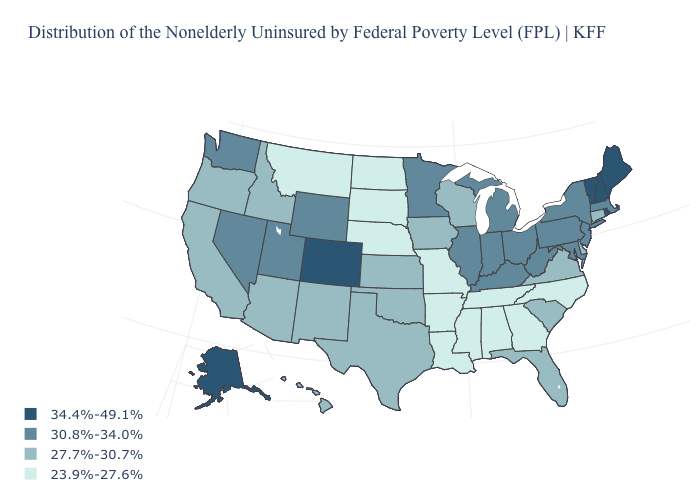Does Tennessee have the lowest value in the USA?
Be succinct. Yes. What is the value of Maine?
Give a very brief answer. 34.4%-49.1%. What is the highest value in the West ?
Short answer required. 34.4%-49.1%. Does the map have missing data?
Answer briefly. No. Does Ohio have the highest value in the MidWest?
Be succinct. Yes. What is the highest value in the USA?
Short answer required. 34.4%-49.1%. Name the states that have a value in the range 30.8%-34.0%?
Short answer required. Illinois, Indiana, Kentucky, Maryland, Massachusetts, Michigan, Minnesota, Nevada, New Jersey, New York, Ohio, Pennsylvania, Utah, Washington, West Virginia, Wyoming. What is the value of Massachusetts?
Quick response, please. 30.8%-34.0%. Does Maryland have the same value as Illinois?
Write a very short answer. Yes. Name the states that have a value in the range 30.8%-34.0%?
Give a very brief answer. Illinois, Indiana, Kentucky, Maryland, Massachusetts, Michigan, Minnesota, Nevada, New Jersey, New York, Ohio, Pennsylvania, Utah, Washington, West Virginia, Wyoming. What is the highest value in the West ?
Write a very short answer. 34.4%-49.1%. Name the states that have a value in the range 23.9%-27.6%?
Concise answer only. Alabama, Arkansas, Georgia, Louisiana, Mississippi, Missouri, Montana, Nebraska, North Carolina, North Dakota, South Dakota, Tennessee. What is the lowest value in states that border Kansas?
Short answer required. 23.9%-27.6%. Name the states that have a value in the range 34.4%-49.1%?
Answer briefly. Alaska, Colorado, Maine, New Hampshire, Rhode Island, Vermont. Does the first symbol in the legend represent the smallest category?
Be succinct. No. 